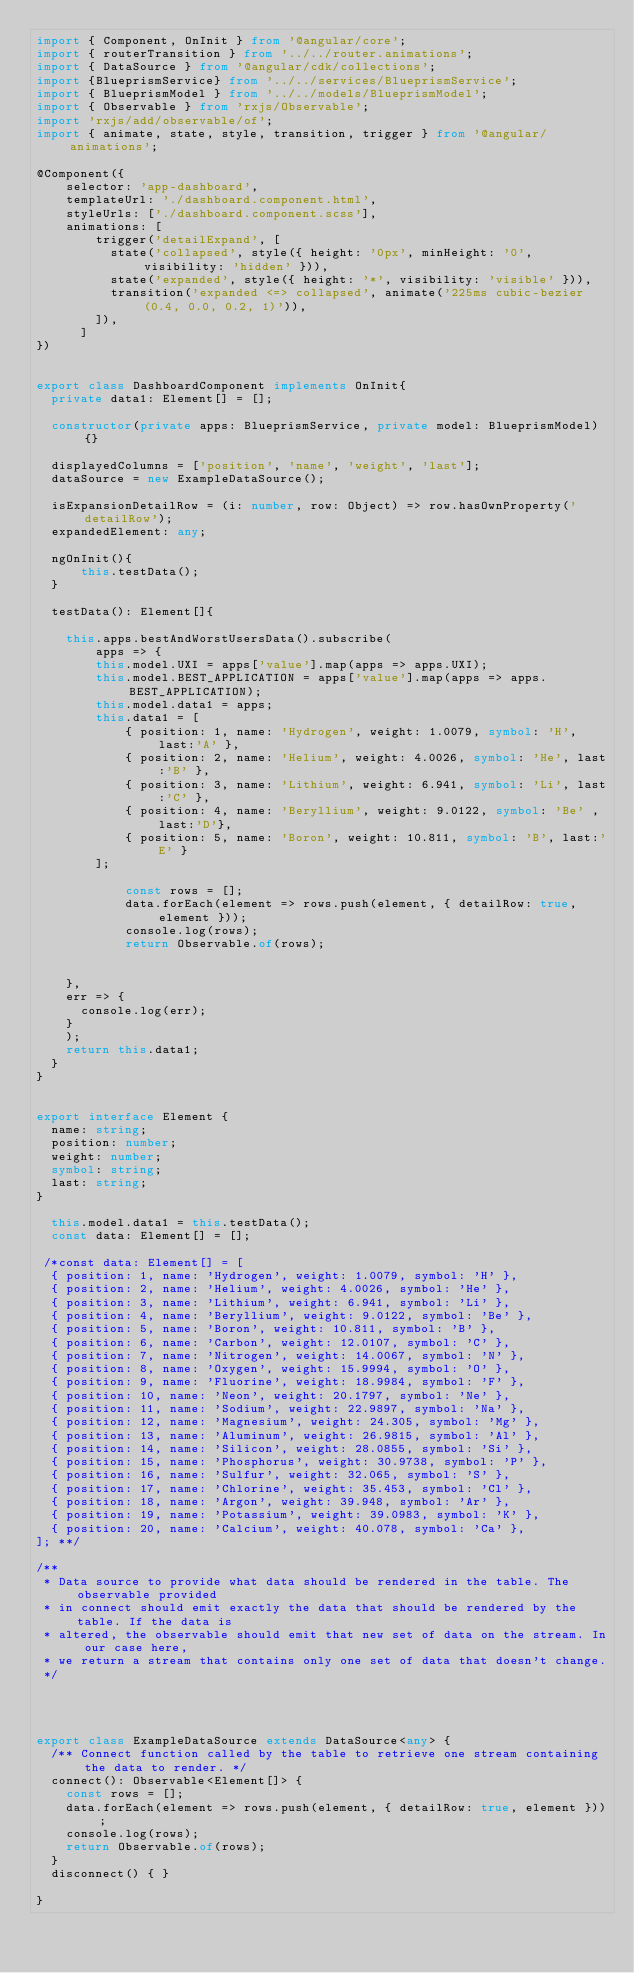<code> <loc_0><loc_0><loc_500><loc_500><_TypeScript_>import { Component, OnInit } from '@angular/core';
import { routerTransition } from '../../router.animations';
import { DataSource } from '@angular/cdk/collections';
import {BlueprismService} from '../../services/BlueprismService';
import { BlueprismModel } from '../../models/BlueprismModel';
import { Observable } from 'rxjs/Observable';
import 'rxjs/add/observable/of';
import { animate, state, style, transition, trigger } from '@angular/animations';

@Component({
    selector: 'app-dashboard',
    templateUrl: './dashboard.component.html',
    styleUrls: ['./dashboard.component.scss'],
    animations: [
        trigger('detailExpand', [
          state('collapsed', style({ height: '0px', minHeight: '0', visibility: 'hidden' })),
          state('expanded', style({ height: '*', visibility: 'visible' })),
          transition('expanded <=> collapsed', animate('225ms cubic-bezier(0.4, 0.0, 0.2, 1)')),
        ]),
      ]
})


export class DashboardComponent implements OnInit{
  private data1: Element[] = [];

  constructor(private apps: BlueprismService, private model: BlueprismModel){}

  displayedColumns = ['position', 'name', 'weight', 'last'];
  dataSource = new ExampleDataSource();

  isExpansionDetailRow = (i: number, row: Object) => row.hasOwnProperty('detailRow');
  expandedElement: any;

  ngOnInit(){
      this.testData();
  }

  testData(): Element[]{

    this.apps.bestAndWorstUsersData().subscribe(
        apps => {
        this.model.UXI = apps['value'].map(apps => apps.UXI);
        this.model.BEST_APPLICATION = apps['value'].map(apps => apps.BEST_APPLICATION);
        this.model.data1 = apps;
        this.data1 = [
            { position: 1, name: 'Hydrogen', weight: 1.0079, symbol: 'H', last:'A' },
            { position: 2, name: 'Helium', weight: 4.0026, symbol: 'He', last:'B' },
            { position: 3, name: 'Lithium', weight: 6.941, symbol: 'Li', last:'C' },
            { position: 4, name: 'Beryllium', weight: 9.0122, symbol: 'Be' , last:'D'},
            { position: 5, name: 'Boron', weight: 10.811, symbol: 'B', last:'E' }
        ];

            const rows = [];
            data.forEach(element => rows.push(element, { detailRow: true, element }));
            console.log(rows);
            return Observable.of(rows);
         
        
    },
    err => {
      console.log(err); 
    }
    );    
    return this.data1;
  } 
}


export interface Element {
  name: string;
  position: number;
  weight: number;
  symbol: string;
  last: string;
}

  this.model.data1 = this.testData();
  const data: Element[] = [];

 /*const data: Element[] = [
  { position: 1, name: 'Hydrogen', weight: 1.0079, symbol: 'H' },
  { position: 2, name: 'Helium', weight: 4.0026, symbol: 'He' },
  { position: 3, name: 'Lithium', weight: 6.941, symbol: 'Li' },
  { position: 4, name: 'Beryllium', weight: 9.0122, symbol: 'Be' },
  { position: 5, name: 'Boron', weight: 10.811, symbol: 'B' },
  { position: 6, name: 'Carbon', weight: 12.0107, symbol: 'C' },
  { position: 7, name: 'Nitrogen', weight: 14.0067, symbol: 'N' },
  { position: 8, name: 'Oxygen', weight: 15.9994, symbol: 'O' },
  { position: 9, name: 'Fluorine', weight: 18.9984, symbol: 'F' },
  { position: 10, name: 'Neon', weight: 20.1797, symbol: 'Ne' },
  { position: 11, name: 'Sodium', weight: 22.9897, symbol: 'Na' },
  { position: 12, name: 'Magnesium', weight: 24.305, symbol: 'Mg' },
  { position: 13, name: 'Aluminum', weight: 26.9815, symbol: 'Al' },
  { position: 14, name: 'Silicon', weight: 28.0855, symbol: 'Si' },
  { position: 15, name: 'Phosphorus', weight: 30.9738, symbol: 'P' },
  { position: 16, name: 'Sulfur', weight: 32.065, symbol: 'S' },
  { position: 17, name: 'Chlorine', weight: 35.453, symbol: 'Cl' },
  { position: 18, name: 'Argon', weight: 39.948, symbol: 'Ar' },
  { position: 19, name: 'Potassium', weight: 39.0983, symbol: 'K' },
  { position: 20, name: 'Calcium', weight: 40.078, symbol: 'Ca' },
]; **/
 
/**
 * Data source to provide what data should be rendered in the table. The observable provided
 * in connect should emit exactly the data that should be rendered by the table. If the data is
 * altered, the observable should emit that new set of data on the stream. In our case here,
 * we return a stream that contains only one set of data that doesn't change.
 */

 


export class ExampleDataSource extends DataSource<any> {
  /** Connect function called by the table to retrieve one stream containing the data to render. */
  connect(): Observable<Element[]> {
    const rows = [];
    data.forEach(element => rows.push(element, { detailRow: true, element }));
    console.log(rows);
    return Observable.of(rows);
  }
  disconnect() { }

}



</code> 